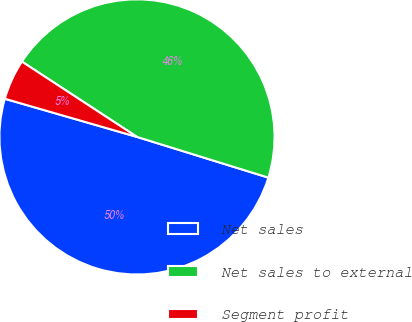Convert chart. <chart><loc_0><loc_0><loc_500><loc_500><pie_chart><fcel>Net sales<fcel>Net sales to external<fcel>Segment profit<nl><fcel>49.69%<fcel>45.56%<fcel>4.75%<nl></chart> 